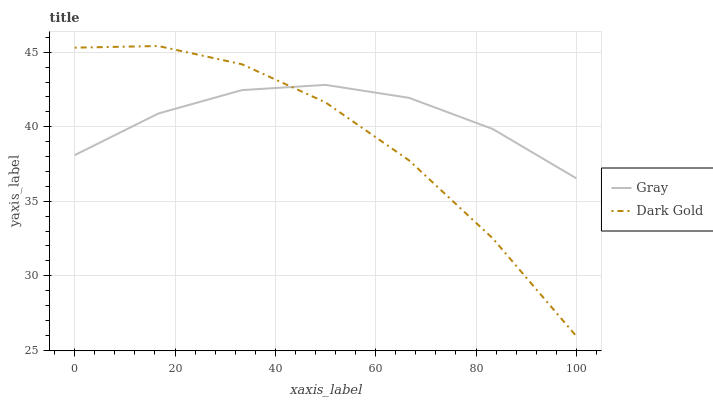Does Dark Gold have the minimum area under the curve?
Answer yes or no. Yes. Does Gray have the maximum area under the curve?
Answer yes or no. Yes. Does Dark Gold have the maximum area under the curve?
Answer yes or no. No. Is Gray the smoothest?
Answer yes or no. Yes. Is Dark Gold the roughest?
Answer yes or no. Yes. Is Dark Gold the smoothest?
Answer yes or no. No. 